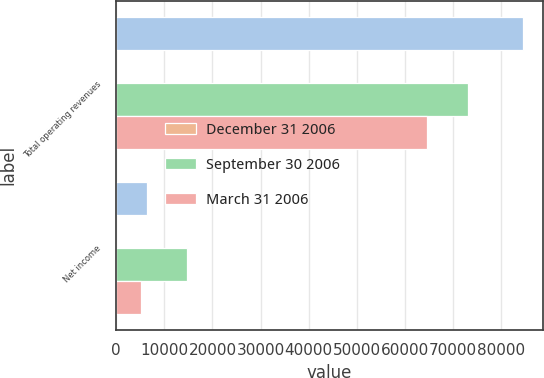Convert chart to OTSL. <chart><loc_0><loc_0><loc_500><loc_500><stacked_bar_chart><ecel><fcel>Total operating revenues<fcel>Net income<nl><fcel>nan<fcel>84514<fcel>6423<nl><fcel>December 31 2006<fcel>1<fcel>2<nl><fcel>September 30 2006<fcel>73189<fcel>14787<nl><fcel>March 31 2006<fcel>64708<fcel>5095<nl></chart> 